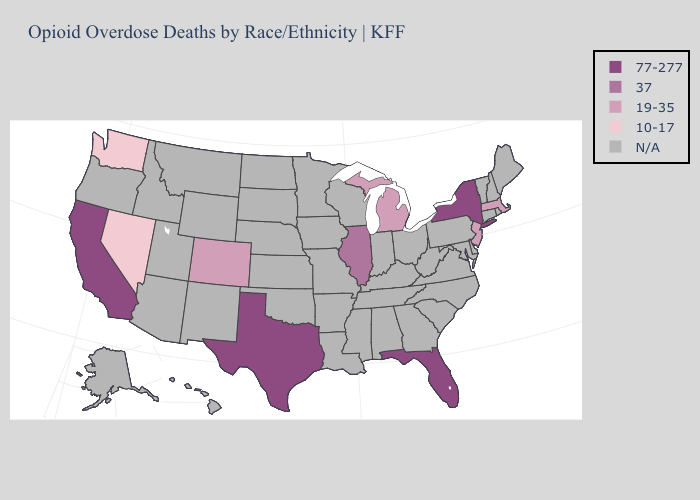What is the highest value in states that border Nevada?
Quick response, please. 77-277. Name the states that have a value in the range 77-277?
Write a very short answer. California, Florida, New York, Texas. Which states hav the highest value in the Northeast?
Short answer required. New York. What is the value of Nevada?
Give a very brief answer. 10-17. What is the lowest value in the USA?
Concise answer only. 10-17. Is the legend a continuous bar?
Answer briefly. No. What is the highest value in the USA?
Keep it brief. 77-277. Does California have the highest value in the USA?
Give a very brief answer. Yes. Name the states that have a value in the range 37?
Write a very short answer. Illinois. Name the states that have a value in the range 37?
Concise answer only. Illinois. What is the highest value in the USA?
Give a very brief answer. 77-277. What is the highest value in the USA?
Write a very short answer. 77-277. Does Massachusetts have the highest value in the Northeast?
Answer briefly. No. Among the states that border Louisiana , which have the highest value?
Answer briefly. Texas. 